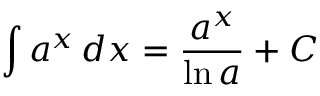<formula> <loc_0><loc_0><loc_500><loc_500>\int a ^ { x } \, d x = { \frac { a ^ { x } } { \ln a } } + C</formula> 